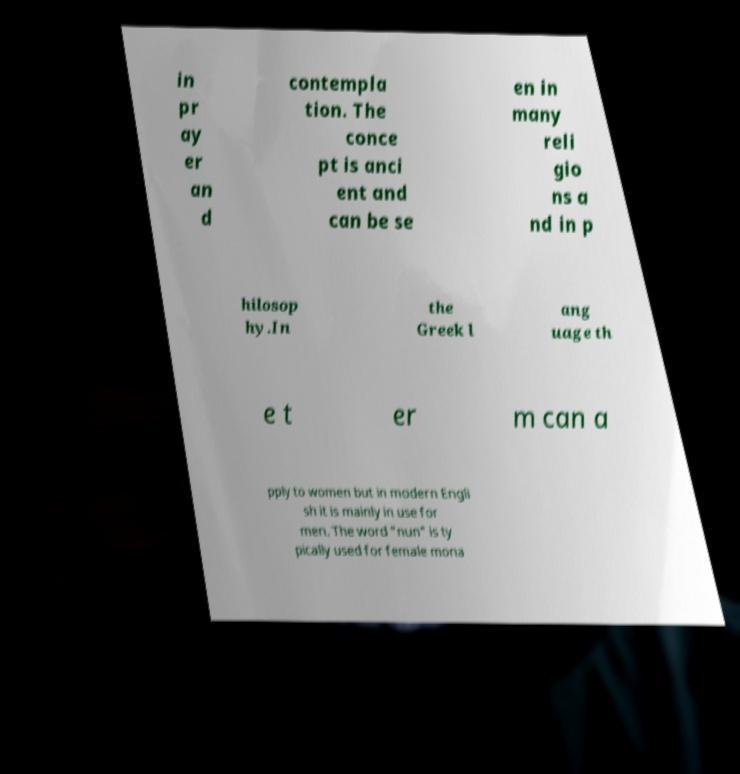Could you assist in decoding the text presented in this image and type it out clearly? in pr ay er an d contempla tion. The conce pt is anci ent and can be se en in many reli gio ns a nd in p hilosop hy.In the Greek l ang uage th e t er m can a pply to women but in modern Engli sh it is mainly in use for men. The word "nun" is ty pically used for female mona 